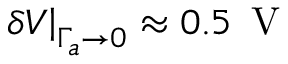<formula> <loc_0><loc_0><loc_500><loc_500>\delta V \right | _ { \Gamma _ { a } \to 0 } \approx 0 . 5 \, V</formula> 